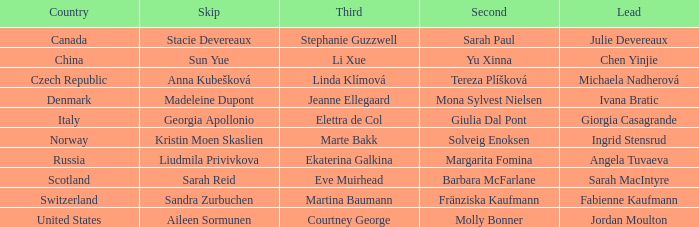What is the second that has jordan moulton as the lead? Molly Bonner. 